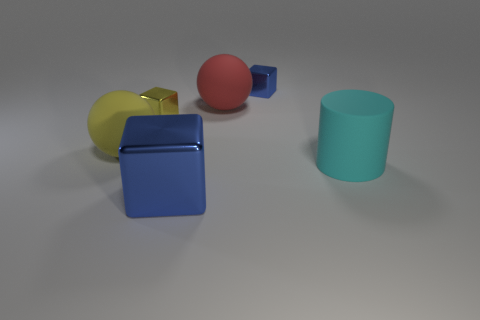Are there an equal number of big blue objects that are left of the tiny yellow object and small cyan cylinders?
Provide a succinct answer. Yes. What number of balls have the same size as the yellow cube?
Make the answer very short. 0. Are there any brown objects?
Your answer should be compact. No. There is a rubber object to the left of the big blue shiny block; is its shape the same as the tiny shiny thing that is to the left of the big shiny object?
Your response must be concise. No. How many tiny things are either yellow shiny cubes or cylinders?
Provide a short and direct response. 1. What is the shape of the cyan thing that is made of the same material as the yellow sphere?
Keep it short and to the point. Cylinder. Does the large yellow matte thing have the same shape as the big cyan thing?
Your response must be concise. No. The cylinder has what color?
Offer a very short reply. Cyan. How many objects are tiny red rubber blocks or small blue shiny things?
Give a very brief answer. 1. Is there anything else that is made of the same material as the tiny blue block?
Your answer should be very brief. Yes. 